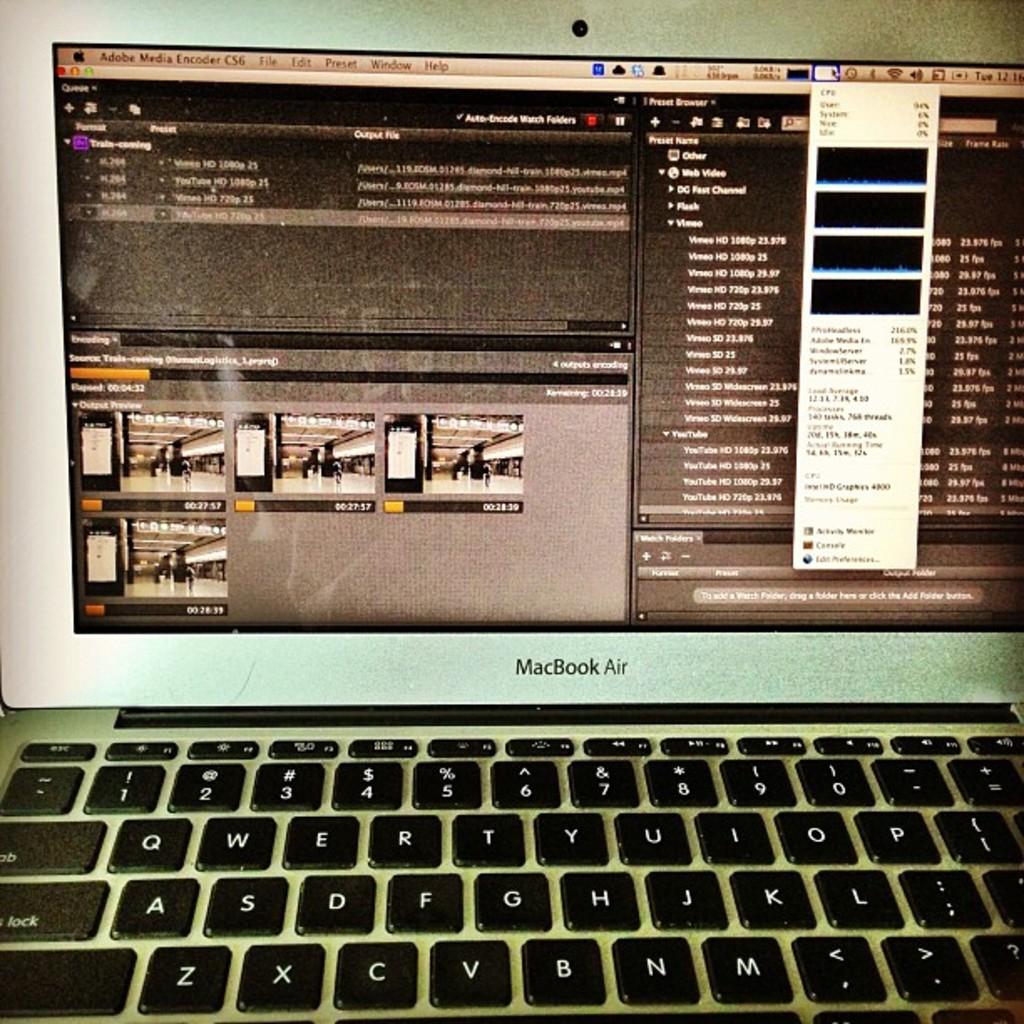What program is open on the macbook?
Provide a succinct answer. Adobe media encoder. What kind of laptop is this?
Provide a succinct answer. Macbook air. 